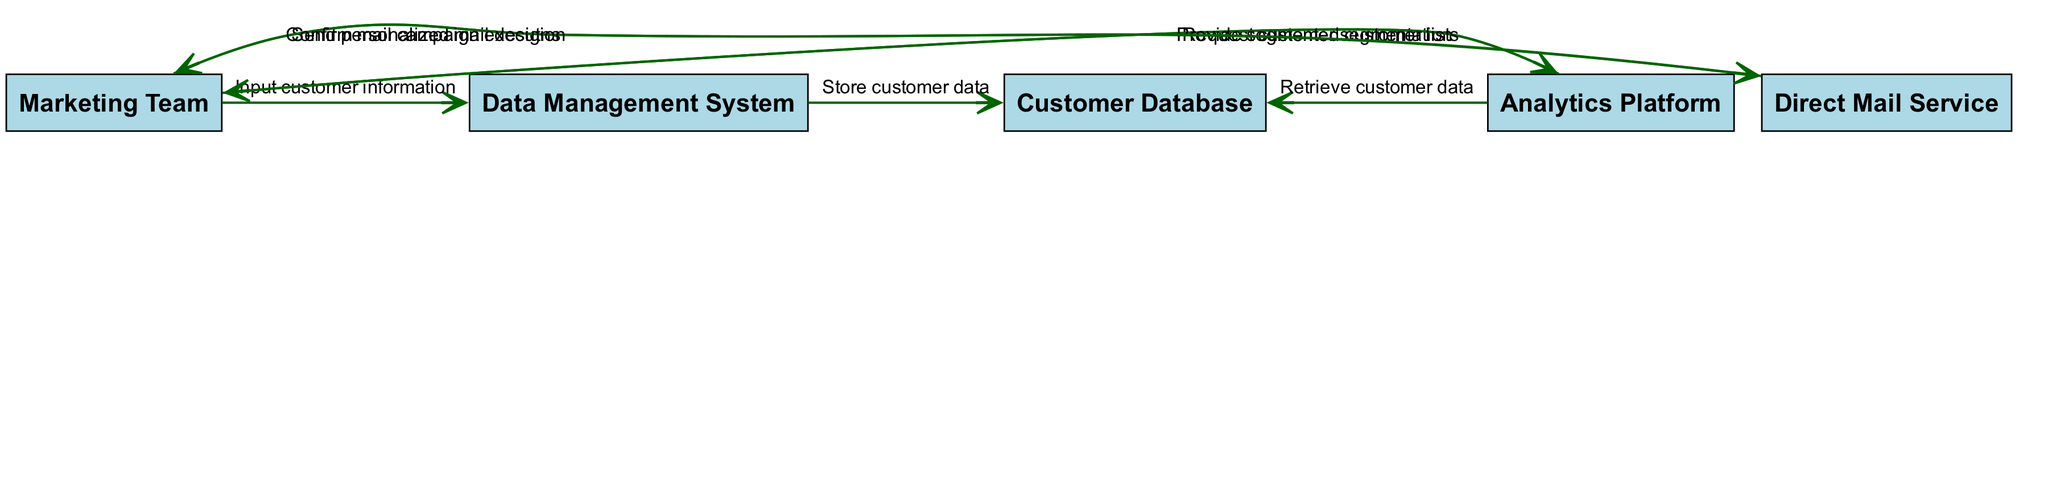What is the first action taken in the process? The first action in the sequence diagram is performed by the Marketing Team when they input customer information into the Data Management System. This is the initial step that begins the process.
Answer: Input customer information How many actors are involved in the sequence diagram? The sequence diagram includes a total of five actors: Marketing Team, Data Management System, Customer Database, Analytics Platform, and Direct Mail Service. This count is based on the nodes representing each actor.
Answer: Five What action does the Analytics Platform take after retrieving customer data? After retrieving customer data from the Customer Database, the Analytics Platform provides segmented customer lists back to the Marketing Team. This follows the flow of actions in the sequence.
Answer: Provide segmented customer lists What relationship does the Marketing Team have with the Direct Mail Service? The relationship is one of sending information; the Marketing Team sends personalized mail designs to the Direct Mail Service in order to execute mail campaigns. This depicts the interaction between these two actors in the process.
Answer: Send personalized mail designs Which actor confirms the campaign execution back to the Marketing Team? The Direct Mail Service confirms the execution of the mail campaign back to the Marketing Team, indicating that the process has moved to completion. This is the final interaction in the sequence.
Answer: Confirm mail campaign execution What is the last action taken in the sequence? The last action in the sequence is the Direct Mail Service confirming the mail campaign execution to the Marketing Team. This completes the flow of actions and signifies the conclusion of the process.
Answer: Confirm mail campaign execution What does the Data Management System do after receiving customer information? After the Marketing Team inputs customer information, the Data Management System stores the customer data into the Customer Database. This step is crucial for setting up future marketing processes.
Answer: Store customer data How does the Marketing Team utilize customer segmentation? The Marketing Team utilizes the customer segmentation provided by the Analytics Platform to send personalized mail designs to the Direct Mail Service, indicating strategic use of the data for targeted marketing.
Answer: Send personalized mail designs 